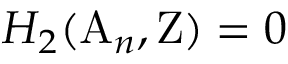<formula> <loc_0><loc_0><loc_500><loc_500>H _ { 2 } ( A _ { n } , Z ) = 0</formula> 